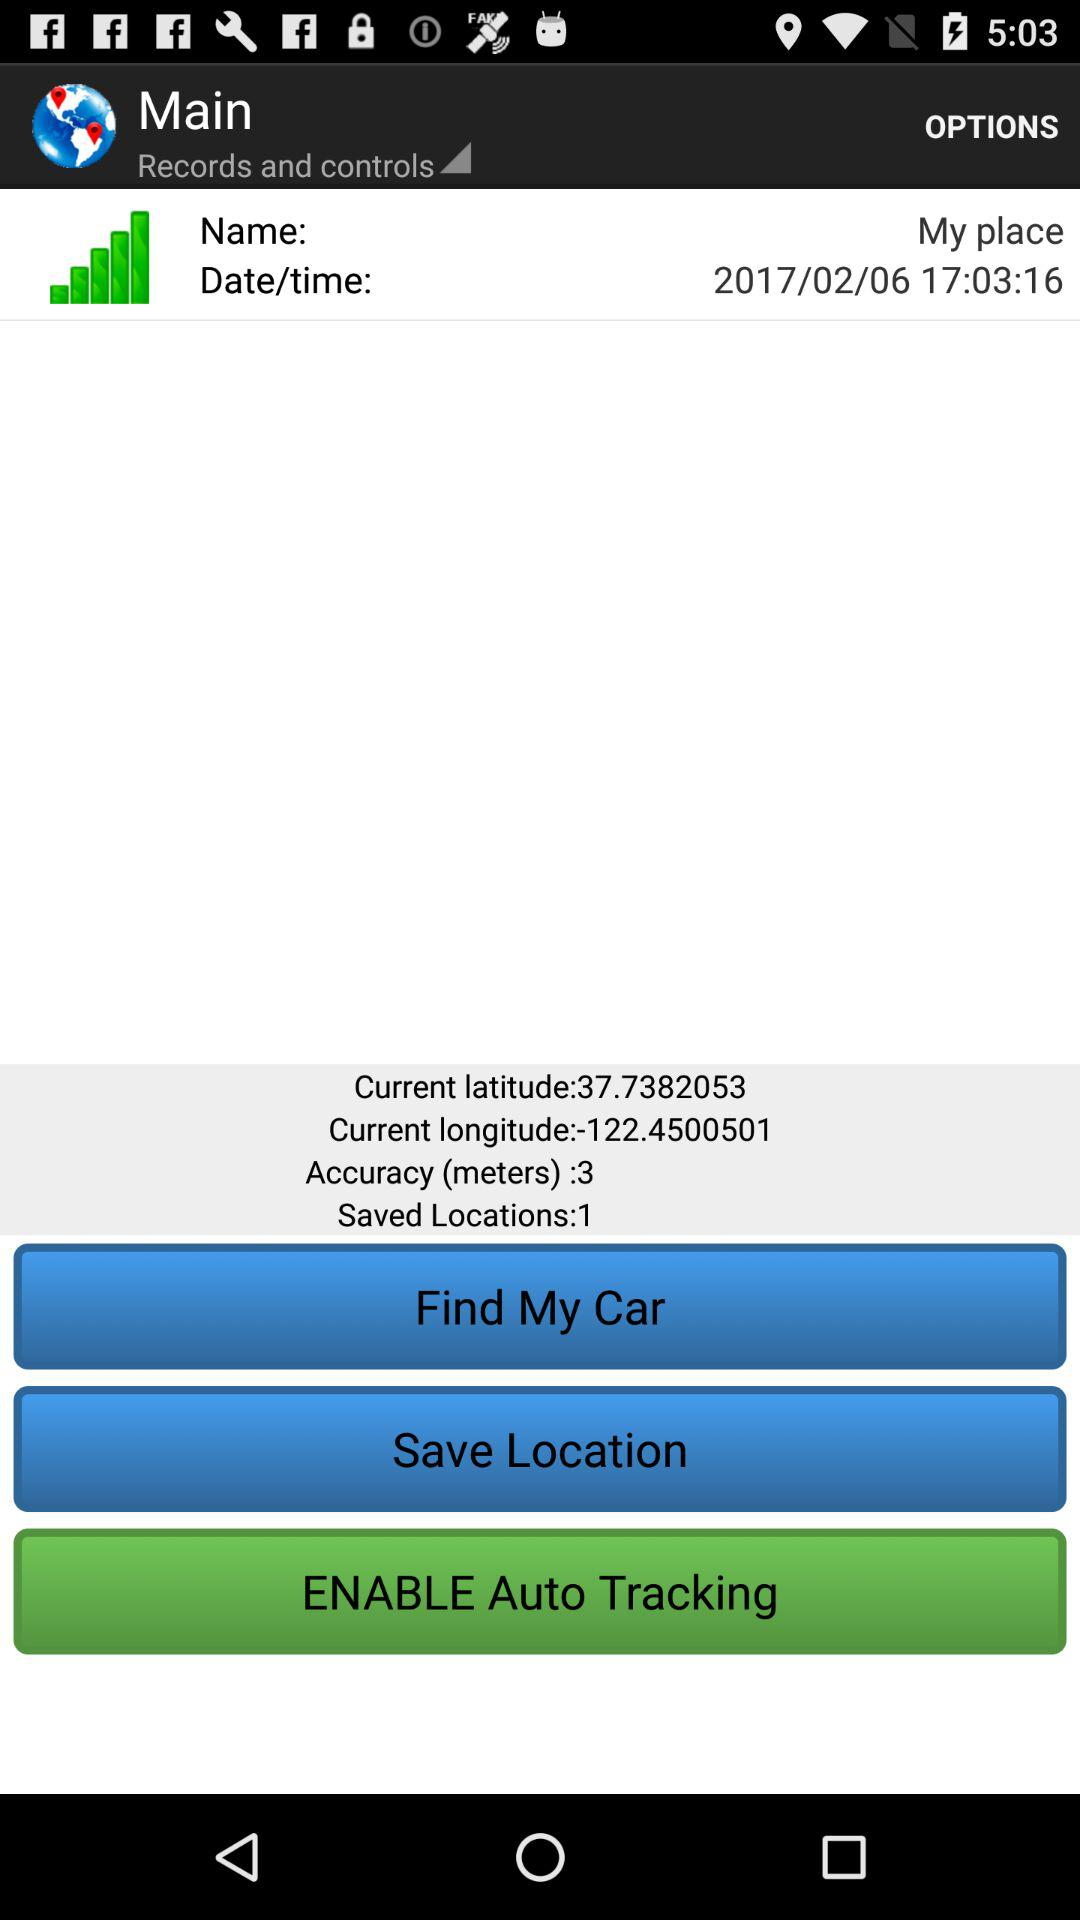What is the accuracy? The accuracy is 3 meters. 